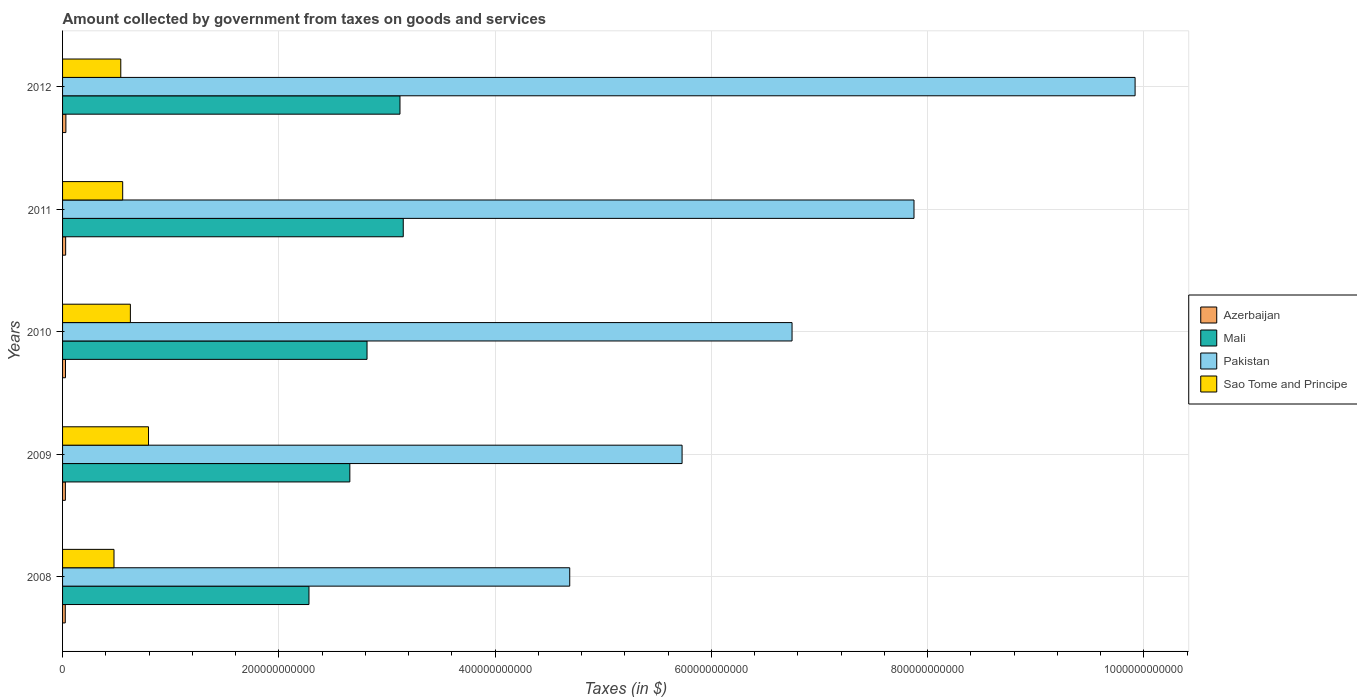How many different coloured bars are there?
Provide a short and direct response. 4. How many groups of bars are there?
Your answer should be compact. 5. Are the number of bars per tick equal to the number of legend labels?
Provide a succinct answer. Yes. How many bars are there on the 4th tick from the top?
Offer a very short reply. 4. How many bars are there on the 4th tick from the bottom?
Provide a succinct answer. 4. What is the label of the 3rd group of bars from the top?
Provide a succinct answer. 2010. In how many cases, is the number of bars for a given year not equal to the number of legend labels?
Offer a terse response. 0. What is the amount collected by government from taxes on goods and services in Sao Tome and Principe in 2011?
Your answer should be compact. 5.56e+1. Across all years, what is the maximum amount collected by government from taxes on goods and services in Mali?
Your answer should be compact. 3.15e+11. Across all years, what is the minimum amount collected by government from taxes on goods and services in Pakistan?
Make the answer very short. 4.69e+11. What is the total amount collected by government from taxes on goods and services in Sao Tome and Principe in the graph?
Your answer should be compact. 2.99e+11. What is the difference between the amount collected by government from taxes on goods and services in Azerbaijan in 2009 and that in 2010?
Keep it short and to the point. -1.03e+08. What is the difference between the amount collected by government from taxes on goods and services in Mali in 2011 and the amount collected by government from taxes on goods and services in Sao Tome and Principe in 2008?
Make the answer very short. 2.68e+11. What is the average amount collected by government from taxes on goods and services in Pakistan per year?
Offer a very short reply. 6.99e+11. In the year 2009, what is the difference between the amount collected by government from taxes on goods and services in Azerbaijan and amount collected by government from taxes on goods and services in Mali?
Provide a short and direct response. -2.63e+11. What is the ratio of the amount collected by government from taxes on goods and services in Azerbaijan in 2011 to that in 2012?
Offer a terse response. 0.93. Is the amount collected by government from taxes on goods and services in Pakistan in 2008 less than that in 2011?
Your response must be concise. Yes. What is the difference between the highest and the second highest amount collected by government from taxes on goods and services in Sao Tome and Principe?
Keep it short and to the point. 1.68e+1. What is the difference between the highest and the lowest amount collected by government from taxes on goods and services in Mali?
Keep it short and to the point. 8.72e+1. In how many years, is the amount collected by government from taxes on goods and services in Sao Tome and Principe greater than the average amount collected by government from taxes on goods and services in Sao Tome and Principe taken over all years?
Keep it short and to the point. 2. Is the sum of the amount collected by government from taxes on goods and services in Azerbaijan in 2009 and 2012 greater than the maximum amount collected by government from taxes on goods and services in Mali across all years?
Offer a terse response. No. Is it the case that in every year, the sum of the amount collected by government from taxes on goods and services in Mali and amount collected by government from taxes on goods and services in Sao Tome and Principe is greater than the sum of amount collected by government from taxes on goods and services in Azerbaijan and amount collected by government from taxes on goods and services in Pakistan?
Keep it short and to the point. No. What does the 3rd bar from the top in 2012 represents?
Give a very brief answer. Mali. What does the 1st bar from the bottom in 2010 represents?
Keep it short and to the point. Azerbaijan. Is it the case that in every year, the sum of the amount collected by government from taxes on goods and services in Sao Tome and Principe and amount collected by government from taxes on goods and services in Mali is greater than the amount collected by government from taxes on goods and services in Pakistan?
Give a very brief answer. No. Are all the bars in the graph horizontal?
Ensure brevity in your answer.  Yes. What is the difference between two consecutive major ticks on the X-axis?
Ensure brevity in your answer.  2.00e+11. Does the graph contain any zero values?
Make the answer very short. No. How many legend labels are there?
Keep it short and to the point. 4. What is the title of the graph?
Ensure brevity in your answer.  Amount collected by government from taxes on goods and services. What is the label or title of the X-axis?
Keep it short and to the point. Taxes (in $). What is the label or title of the Y-axis?
Your answer should be compact. Years. What is the Taxes (in $) in Azerbaijan in 2008?
Provide a short and direct response. 2.50e+09. What is the Taxes (in $) of Mali in 2008?
Your answer should be compact. 2.28e+11. What is the Taxes (in $) in Pakistan in 2008?
Offer a very short reply. 4.69e+11. What is the Taxes (in $) in Sao Tome and Principe in 2008?
Make the answer very short. 4.76e+1. What is the Taxes (in $) of Azerbaijan in 2009?
Give a very brief answer. 2.59e+09. What is the Taxes (in $) of Mali in 2009?
Provide a short and direct response. 2.66e+11. What is the Taxes (in $) in Pakistan in 2009?
Your answer should be very brief. 5.73e+11. What is the Taxes (in $) of Sao Tome and Principe in 2009?
Provide a short and direct response. 7.95e+1. What is the Taxes (in $) in Azerbaijan in 2010?
Make the answer very short. 2.70e+09. What is the Taxes (in $) in Mali in 2010?
Your response must be concise. 2.82e+11. What is the Taxes (in $) in Pakistan in 2010?
Offer a very short reply. 6.75e+11. What is the Taxes (in $) in Sao Tome and Principe in 2010?
Your answer should be very brief. 6.27e+1. What is the Taxes (in $) in Azerbaijan in 2011?
Make the answer very short. 2.87e+09. What is the Taxes (in $) of Mali in 2011?
Ensure brevity in your answer.  3.15e+11. What is the Taxes (in $) in Pakistan in 2011?
Your answer should be compact. 7.88e+11. What is the Taxes (in $) of Sao Tome and Principe in 2011?
Provide a short and direct response. 5.56e+1. What is the Taxes (in $) of Azerbaijan in 2012?
Your answer should be compact. 3.08e+09. What is the Taxes (in $) of Mali in 2012?
Offer a very short reply. 3.12e+11. What is the Taxes (in $) in Pakistan in 2012?
Keep it short and to the point. 9.92e+11. What is the Taxes (in $) of Sao Tome and Principe in 2012?
Your answer should be very brief. 5.38e+1. Across all years, what is the maximum Taxes (in $) of Azerbaijan?
Your answer should be compact. 3.08e+09. Across all years, what is the maximum Taxes (in $) of Mali?
Keep it short and to the point. 3.15e+11. Across all years, what is the maximum Taxes (in $) of Pakistan?
Keep it short and to the point. 9.92e+11. Across all years, what is the maximum Taxes (in $) in Sao Tome and Principe?
Provide a short and direct response. 7.95e+1. Across all years, what is the minimum Taxes (in $) of Azerbaijan?
Your response must be concise. 2.50e+09. Across all years, what is the minimum Taxes (in $) in Mali?
Ensure brevity in your answer.  2.28e+11. Across all years, what is the minimum Taxes (in $) of Pakistan?
Your answer should be compact. 4.69e+11. Across all years, what is the minimum Taxes (in $) in Sao Tome and Principe?
Your response must be concise. 4.76e+1. What is the total Taxes (in $) of Azerbaijan in the graph?
Your answer should be compact. 1.37e+1. What is the total Taxes (in $) of Mali in the graph?
Your response must be concise. 1.40e+12. What is the total Taxes (in $) in Pakistan in the graph?
Your answer should be very brief. 3.50e+12. What is the total Taxes (in $) in Sao Tome and Principe in the graph?
Keep it short and to the point. 2.99e+11. What is the difference between the Taxes (in $) of Azerbaijan in 2008 and that in 2009?
Give a very brief answer. -9.02e+07. What is the difference between the Taxes (in $) in Mali in 2008 and that in 2009?
Your answer should be compact. -3.78e+1. What is the difference between the Taxes (in $) of Pakistan in 2008 and that in 2009?
Offer a terse response. -1.04e+11. What is the difference between the Taxes (in $) in Sao Tome and Principe in 2008 and that in 2009?
Ensure brevity in your answer.  -3.19e+1. What is the difference between the Taxes (in $) in Azerbaijan in 2008 and that in 2010?
Offer a terse response. -1.93e+08. What is the difference between the Taxes (in $) of Mali in 2008 and that in 2010?
Provide a short and direct response. -5.37e+1. What is the difference between the Taxes (in $) in Pakistan in 2008 and that in 2010?
Provide a short and direct response. -2.06e+11. What is the difference between the Taxes (in $) of Sao Tome and Principe in 2008 and that in 2010?
Your response must be concise. -1.52e+1. What is the difference between the Taxes (in $) in Azerbaijan in 2008 and that in 2011?
Your answer should be very brief. -3.62e+08. What is the difference between the Taxes (in $) of Mali in 2008 and that in 2011?
Ensure brevity in your answer.  -8.72e+1. What is the difference between the Taxes (in $) in Pakistan in 2008 and that in 2011?
Provide a succinct answer. -3.18e+11. What is the difference between the Taxes (in $) of Sao Tome and Principe in 2008 and that in 2011?
Your answer should be very brief. -8.04e+09. What is the difference between the Taxes (in $) in Azerbaijan in 2008 and that in 2012?
Provide a succinct answer. -5.77e+08. What is the difference between the Taxes (in $) in Mali in 2008 and that in 2012?
Provide a succinct answer. -8.42e+1. What is the difference between the Taxes (in $) of Pakistan in 2008 and that in 2012?
Ensure brevity in your answer.  -5.23e+11. What is the difference between the Taxes (in $) in Sao Tome and Principe in 2008 and that in 2012?
Offer a very short reply. -6.28e+09. What is the difference between the Taxes (in $) of Azerbaijan in 2009 and that in 2010?
Offer a very short reply. -1.03e+08. What is the difference between the Taxes (in $) in Mali in 2009 and that in 2010?
Ensure brevity in your answer.  -1.59e+1. What is the difference between the Taxes (in $) of Pakistan in 2009 and that in 2010?
Your answer should be compact. -1.02e+11. What is the difference between the Taxes (in $) of Sao Tome and Principe in 2009 and that in 2010?
Offer a very short reply. 1.68e+1. What is the difference between the Taxes (in $) of Azerbaijan in 2009 and that in 2011?
Your answer should be very brief. -2.72e+08. What is the difference between the Taxes (in $) of Mali in 2009 and that in 2011?
Ensure brevity in your answer.  -4.94e+1. What is the difference between the Taxes (in $) of Pakistan in 2009 and that in 2011?
Provide a succinct answer. -2.14e+11. What is the difference between the Taxes (in $) in Sao Tome and Principe in 2009 and that in 2011?
Give a very brief answer. 2.39e+1. What is the difference between the Taxes (in $) in Azerbaijan in 2009 and that in 2012?
Provide a short and direct response. -4.87e+08. What is the difference between the Taxes (in $) of Mali in 2009 and that in 2012?
Your answer should be compact. -4.64e+1. What is the difference between the Taxes (in $) of Pakistan in 2009 and that in 2012?
Keep it short and to the point. -4.19e+11. What is the difference between the Taxes (in $) in Sao Tome and Principe in 2009 and that in 2012?
Keep it short and to the point. 2.57e+1. What is the difference between the Taxes (in $) of Azerbaijan in 2010 and that in 2011?
Offer a terse response. -1.70e+08. What is the difference between the Taxes (in $) in Mali in 2010 and that in 2011?
Keep it short and to the point. -3.35e+1. What is the difference between the Taxes (in $) in Pakistan in 2010 and that in 2011?
Offer a terse response. -1.13e+11. What is the difference between the Taxes (in $) in Sao Tome and Principe in 2010 and that in 2011?
Offer a very short reply. 7.12e+09. What is the difference between the Taxes (in $) of Azerbaijan in 2010 and that in 2012?
Your answer should be compact. -3.85e+08. What is the difference between the Taxes (in $) of Mali in 2010 and that in 2012?
Your answer should be very brief. -3.05e+1. What is the difference between the Taxes (in $) in Pakistan in 2010 and that in 2012?
Offer a very short reply. -3.17e+11. What is the difference between the Taxes (in $) in Sao Tome and Principe in 2010 and that in 2012?
Ensure brevity in your answer.  8.88e+09. What is the difference between the Taxes (in $) in Azerbaijan in 2011 and that in 2012?
Provide a short and direct response. -2.15e+08. What is the difference between the Taxes (in $) in Mali in 2011 and that in 2012?
Make the answer very short. 3.02e+09. What is the difference between the Taxes (in $) in Pakistan in 2011 and that in 2012?
Offer a terse response. -2.04e+11. What is the difference between the Taxes (in $) of Sao Tome and Principe in 2011 and that in 2012?
Your answer should be compact. 1.76e+09. What is the difference between the Taxes (in $) of Azerbaijan in 2008 and the Taxes (in $) of Mali in 2009?
Keep it short and to the point. -2.63e+11. What is the difference between the Taxes (in $) in Azerbaijan in 2008 and the Taxes (in $) in Pakistan in 2009?
Offer a very short reply. -5.70e+11. What is the difference between the Taxes (in $) in Azerbaijan in 2008 and the Taxes (in $) in Sao Tome and Principe in 2009?
Your answer should be compact. -7.70e+1. What is the difference between the Taxes (in $) of Mali in 2008 and the Taxes (in $) of Pakistan in 2009?
Your answer should be compact. -3.45e+11. What is the difference between the Taxes (in $) in Mali in 2008 and the Taxes (in $) in Sao Tome and Principe in 2009?
Your answer should be compact. 1.48e+11. What is the difference between the Taxes (in $) of Pakistan in 2008 and the Taxes (in $) of Sao Tome and Principe in 2009?
Your answer should be compact. 3.90e+11. What is the difference between the Taxes (in $) in Azerbaijan in 2008 and the Taxes (in $) in Mali in 2010?
Ensure brevity in your answer.  -2.79e+11. What is the difference between the Taxes (in $) of Azerbaijan in 2008 and the Taxes (in $) of Pakistan in 2010?
Give a very brief answer. -6.72e+11. What is the difference between the Taxes (in $) of Azerbaijan in 2008 and the Taxes (in $) of Sao Tome and Principe in 2010?
Provide a short and direct response. -6.02e+1. What is the difference between the Taxes (in $) in Mali in 2008 and the Taxes (in $) in Pakistan in 2010?
Provide a succinct answer. -4.47e+11. What is the difference between the Taxes (in $) of Mali in 2008 and the Taxes (in $) of Sao Tome and Principe in 2010?
Ensure brevity in your answer.  1.65e+11. What is the difference between the Taxes (in $) of Pakistan in 2008 and the Taxes (in $) of Sao Tome and Principe in 2010?
Provide a succinct answer. 4.06e+11. What is the difference between the Taxes (in $) in Azerbaijan in 2008 and the Taxes (in $) in Mali in 2011?
Provide a short and direct response. -3.13e+11. What is the difference between the Taxes (in $) of Azerbaijan in 2008 and the Taxes (in $) of Pakistan in 2011?
Give a very brief answer. -7.85e+11. What is the difference between the Taxes (in $) of Azerbaijan in 2008 and the Taxes (in $) of Sao Tome and Principe in 2011?
Ensure brevity in your answer.  -5.31e+1. What is the difference between the Taxes (in $) in Mali in 2008 and the Taxes (in $) in Pakistan in 2011?
Make the answer very short. -5.60e+11. What is the difference between the Taxes (in $) of Mali in 2008 and the Taxes (in $) of Sao Tome and Principe in 2011?
Offer a very short reply. 1.72e+11. What is the difference between the Taxes (in $) of Pakistan in 2008 and the Taxes (in $) of Sao Tome and Principe in 2011?
Offer a very short reply. 4.13e+11. What is the difference between the Taxes (in $) in Azerbaijan in 2008 and the Taxes (in $) in Mali in 2012?
Offer a terse response. -3.10e+11. What is the difference between the Taxes (in $) in Azerbaijan in 2008 and the Taxes (in $) in Pakistan in 2012?
Keep it short and to the point. -9.89e+11. What is the difference between the Taxes (in $) of Azerbaijan in 2008 and the Taxes (in $) of Sao Tome and Principe in 2012?
Your response must be concise. -5.13e+1. What is the difference between the Taxes (in $) of Mali in 2008 and the Taxes (in $) of Pakistan in 2012?
Provide a succinct answer. -7.64e+11. What is the difference between the Taxes (in $) of Mali in 2008 and the Taxes (in $) of Sao Tome and Principe in 2012?
Your response must be concise. 1.74e+11. What is the difference between the Taxes (in $) of Pakistan in 2008 and the Taxes (in $) of Sao Tome and Principe in 2012?
Provide a short and direct response. 4.15e+11. What is the difference between the Taxes (in $) in Azerbaijan in 2009 and the Taxes (in $) in Mali in 2010?
Make the answer very short. -2.79e+11. What is the difference between the Taxes (in $) of Azerbaijan in 2009 and the Taxes (in $) of Pakistan in 2010?
Keep it short and to the point. -6.72e+11. What is the difference between the Taxes (in $) in Azerbaijan in 2009 and the Taxes (in $) in Sao Tome and Principe in 2010?
Your response must be concise. -6.01e+1. What is the difference between the Taxes (in $) of Mali in 2009 and the Taxes (in $) of Pakistan in 2010?
Your answer should be very brief. -4.09e+11. What is the difference between the Taxes (in $) of Mali in 2009 and the Taxes (in $) of Sao Tome and Principe in 2010?
Your answer should be very brief. 2.03e+11. What is the difference between the Taxes (in $) in Pakistan in 2009 and the Taxes (in $) in Sao Tome and Principe in 2010?
Your response must be concise. 5.10e+11. What is the difference between the Taxes (in $) of Azerbaijan in 2009 and the Taxes (in $) of Mali in 2011?
Provide a short and direct response. -3.13e+11. What is the difference between the Taxes (in $) of Azerbaijan in 2009 and the Taxes (in $) of Pakistan in 2011?
Your response must be concise. -7.85e+11. What is the difference between the Taxes (in $) in Azerbaijan in 2009 and the Taxes (in $) in Sao Tome and Principe in 2011?
Keep it short and to the point. -5.30e+1. What is the difference between the Taxes (in $) of Mali in 2009 and the Taxes (in $) of Pakistan in 2011?
Give a very brief answer. -5.22e+11. What is the difference between the Taxes (in $) in Mali in 2009 and the Taxes (in $) in Sao Tome and Principe in 2011?
Keep it short and to the point. 2.10e+11. What is the difference between the Taxes (in $) in Pakistan in 2009 and the Taxes (in $) in Sao Tome and Principe in 2011?
Make the answer very short. 5.17e+11. What is the difference between the Taxes (in $) of Azerbaijan in 2009 and the Taxes (in $) of Mali in 2012?
Offer a terse response. -3.09e+11. What is the difference between the Taxes (in $) of Azerbaijan in 2009 and the Taxes (in $) of Pakistan in 2012?
Offer a very short reply. -9.89e+11. What is the difference between the Taxes (in $) in Azerbaijan in 2009 and the Taxes (in $) in Sao Tome and Principe in 2012?
Offer a very short reply. -5.13e+1. What is the difference between the Taxes (in $) of Mali in 2009 and the Taxes (in $) of Pakistan in 2012?
Your answer should be very brief. -7.26e+11. What is the difference between the Taxes (in $) in Mali in 2009 and the Taxes (in $) in Sao Tome and Principe in 2012?
Offer a very short reply. 2.12e+11. What is the difference between the Taxes (in $) of Pakistan in 2009 and the Taxes (in $) of Sao Tome and Principe in 2012?
Offer a terse response. 5.19e+11. What is the difference between the Taxes (in $) of Azerbaijan in 2010 and the Taxes (in $) of Mali in 2011?
Provide a short and direct response. -3.12e+11. What is the difference between the Taxes (in $) of Azerbaijan in 2010 and the Taxes (in $) of Pakistan in 2011?
Offer a very short reply. -7.85e+11. What is the difference between the Taxes (in $) of Azerbaijan in 2010 and the Taxes (in $) of Sao Tome and Principe in 2011?
Offer a very short reply. -5.29e+1. What is the difference between the Taxes (in $) of Mali in 2010 and the Taxes (in $) of Pakistan in 2011?
Provide a succinct answer. -5.06e+11. What is the difference between the Taxes (in $) of Mali in 2010 and the Taxes (in $) of Sao Tome and Principe in 2011?
Offer a very short reply. 2.26e+11. What is the difference between the Taxes (in $) in Pakistan in 2010 and the Taxes (in $) in Sao Tome and Principe in 2011?
Provide a short and direct response. 6.19e+11. What is the difference between the Taxes (in $) of Azerbaijan in 2010 and the Taxes (in $) of Mali in 2012?
Offer a terse response. -3.09e+11. What is the difference between the Taxes (in $) in Azerbaijan in 2010 and the Taxes (in $) in Pakistan in 2012?
Give a very brief answer. -9.89e+11. What is the difference between the Taxes (in $) in Azerbaijan in 2010 and the Taxes (in $) in Sao Tome and Principe in 2012?
Your response must be concise. -5.12e+1. What is the difference between the Taxes (in $) of Mali in 2010 and the Taxes (in $) of Pakistan in 2012?
Keep it short and to the point. -7.10e+11. What is the difference between the Taxes (in $) in Mali in 2010 and the Taxes (in $) in Sao Tome and Principe in 2012?
Provide a short and direct response. 2.28e+11. What is the difference between the Taxes (in $) of Pakistan in 2010 and the Taxes (in $) of Sao Tome and Principe in 2012?
Your answer should be very brief. 6.21e+11. What is the difference between the Taxes (in $) of Azerbaijan in 2011 and the Taxes (in $) of Mali in 2012?
Provide a succinct answer. -3.09e+11. What is the difference between the Taxes (in $) in Azerbaijan in 2011 and the Taxes (in $) in Pakistan in 2012?
Provide a short and direct response. -9.89e+11. What is the difference between the Taxes (in $) of Azerbaijan in 2011 and the Taxes (in $) of Sao Tome and Principe in 2012?
Your answer should be very brief. -5.10e+1. What is the difference between the Taxes (in $) of Mali in 2011 and the Taxes (in $) of Pakistan in 2012?
Your response must be concise. -6.77e+11. What is the difference between the Taxes (in $) in Mali in 2011 and the Taxes (in $) in Sao Tome and Principe in 2012?
Make the answer very short. 2.61e+11. What is the difference between the Taxes (in $) of Pakistan in 2011 and the Taxes (in $) of Sao Tome and Principe in 2012?
Your answer should be compact. 7.34e+11. What is the average Taxes (in $) of Azerbaijan per year?
Your response must be concise. 2.75e+09. What is the average Taxes (in $) in Mali per year?
Offer a very short reply. 2.80e+11. What is the average Taxes (in $) in Pakistan per year?
Offer a terse response. 6.99e+11. What is the average Taxes (in $) of Sao Tome and Principe per year?
Offer a terse response. 5.98e+1. In the year 2008, what is the difference between the Taxes (in $) in Azerbaijan and Taxes (in $) in Mali?
Offer a terse response. -2.25e+11. In the year 2008, what is the difference between the Taxes (in $) in Azerbaijan and Taxes (in $) in Pakistan?
Offer a very short reply. -4.67e+11. In the year 2008, what is the difference between the Taxes (in $) of Azerbaijan and Taxes (in $) of Sao Tome and Principe?
Keep it short and to the point. -4.51e+1. In the year 2008, what is the difference between the Taxes (in $) of Mali and Taxes (in $) of Pakistan?
Offer a terse response. -2.41e+11. In the year 2008, what is the difference between the Taxes (in $) of Mali and Taxes (in $) of Sao Tome and Principe?
Keep it short and to the point. 1.80e+11. In the year 2008, what is the difference between the Taxes (in $) in Pakistan and Taxes (in $) in Sao Tome and Principe?
Offer a very short reply. 4.22e+11. In the year 2009, what is the difference between the Taxes (in $) of Azerbaijan and Taxes (in $) of Mali?
Keep it short and to the point. -2.63e+11. In the year 2009, what is the difference between the Taxes (in $) in Azerbaijan and Taxes (in $) in Pakistan?
Your response must be concise. -5.70e+11. In the year 2009, what is the difference between the Taxes (in $) of Azerbaijan and Taxes (in $) of Sao Tome and Principe?
Provide a succinct answer. -7.69e+1. In the year 2009, what is the difference between the Taxes (in $) in Mali and Taxes (in $) in Pakistan?
Your response must be concise. -3.07e+11. In the year 2009, what is the difference between the Taxes (in $) in Mali and Taxes (in $) in Sao Tome and Principe?
Offer a terse response. 1.86e+11. In the year 2009, what is the difference between the Taxes (in $) of Pakistan and Taxes (in $) of Sao Tome and Principe?
Offer a terse response. 4.93e+11. In the year 2010, what is the difference between the Taxes (in $) of Azerbaijan and Taxes (in $) of Mali?
Your response must be concise. -2.79e+11. In the year 2010, what is the difference between the Taxes (in $) of Azerbaijan and Taxes (in $) of Pakistan?
Offer a very short reply. -6.72e+11. In the year 2010, what is the difference between the Taxes (in $) in Azerbaijan and Taxes (in $) in Sao Tome and Principe?
Make the answer very short. -6.00e+1. In the year 2010, what is the difference between the Taxes (in $) of Mali and Taxes (in $) of Pakistan?
Ensure brevity in your answer.  -3.93e+11. In the year 2010, what is the difference between the Taxes (in $) of Mali and Taxes (in $) of Sao Tome and Principe?
Offer a very short reply. 2.19e+11. In the year 2010, what is the difference between the Taxes (in $) in Pakistan and Taxes (in $) in Sao Tome and Principe?
Make the answer very short. 6.12e+11. In the year 2011, what is the difference between the Taxes (in $) in Azerbaijan and Taxes (in $) in Mali?
Make the answer very short. -3.12e+11. In the year 2011, what is the difference between the Taxes (in $) of Azerbaijan and Taxes (in $) of Pakistan?
Your answer should be very brief. -7.85e+11. In the year 2011, what is the difference between the Taxes (in $) in Azerbaijan and Taxes (in $) in Sao Tome and Principe?
Your answer should be compact. -5.27e+1. In the year 2011, what is the difference between the Taxes (in $) of Mali and Taxes (in $) of Pakistan?
Your response must be concise. -4.72e+11. In the year 2011, what is the difference between the Taxes (in $) in Mali and Taxes (in $) in Sao Tome and Principe?
Your response must be concise. 2.60e+11. In the year 2011, what is the difference between the Taxes (in $) of Pakistan and Taxes (in $) of Sao Tome and Principe?
Offer a terse response. 7.32e+11. In the year 2012, what is the difference between the Taxes (in $) of Azerbaijan and Taxes (in $) of Mali?
Provide a succinct answer. -3.09e+11. In the year 2012, what is the difference between the Taxes (in $) of Azerbaijan and Taxes (in $) of Pakistan?
Offer a very short reply. -9.89e+11. In the year 2012, what is the difference between the Taxes (in $) in Azerbaijan and Taxes (in $) in Sao Tome and Principe?
Provide a short and direct response. -5.08e+1. In the year 2012, what is the difference between the Taxes (in $) in Mali and Taxes (in $) in Pakistan?
Provide a succinct answer. -6.80e+11. In the year 2012, what is the difference between the Taxes (in $) of Mali and Taxes (in $) of Sao Tome and Principe?
Provide a short and direct response. 2.58e+11. In the year 2012, what is the difference between the Taxes (in $) in Pakistan and Taxes (in $) in Sao Tome and Principe?
Provide a succinct answer. 9.38e+11. What is the ratio of the Taxes (in $) of Azerbaijan in 2008 to that in 2009?
Provide a short and direct response. 0.97. What is the ratio of the Taxes (in $) in Mali in 2008 to that in 2009?
Make the answer very short. 0.86. What is the ratio of the Taxes (in $) in Pakistan in 2008 to that in 2009?
Provide a short and direct response. 0.82. What is the ratio of the Taxes (in $) in Sao Tome and Principe in 2008 to that in 2009?
Your response must be concise. 0.6. What is the ratio of the Taxes (in $) of Azerbaijan in 2008 to that in 2010?
Provide a short and direct response. 0.93. What is the ratio of the Taxes (in $) in Mali in 2008 to that in 2010?
Your answer should be compact. 0.81. What is the ratio of the Taxes (in $) of Pakistan in 2008 to that in 2010?
Offer a very short reply. 0.7. What is the ratio of the Taxes (in $) in Sao Tome and Principe in 2008 to that in 2010?
Your answer should be very brief. 0.76. What is the ratio of the Taxes (in $) in Azerbaijan in 2008 to that in 2011?
Keep it short and to the point. 0.87. What is the ratio of the Taxes (in $) of Mali in 2008 to that in 2011?
Ensure brevity in your answer.  0.72. What is the ratio of the Taxes (in $) of Pakistan in 2008 to that in 2011?
Offer a terse response. 0.6. What is the ratio of the Taxes (in $) of Sao Tome and Principe in 2008 to that in 2011?
Keep it short and to the point. 0.86. What is the ratio of the Taxes (in $) of Azerbaijan in 2008 to that in 2012?
Offer a terse response. 0.81. What is the ratio of the Taxes (in $) in Mali in 2008 to that in 2012?
Ensure brevity in your answer.  0.73. What is the ratio of the Taxes (in $) in Pakistan in 2008 to that in 2012?
Offer a terse response. 0.47. What is the ratio of the Taxes (in $) in Sao Tome and Principe in 2008 to that in 2012?
Make the answer very short. 0.88. What is the ratio of the Taxes (in $) in Azerbaijan in 2009 to that in 2010?
Offer a terse response. 0.96. What is the ratio of the Taxes (in $) of Mali in 2009 to that in 2010?
Your response must be concise. 0.94. What is the ratio of the Taxes (in $) in Pakistan in 2009 to that in 2010?
Ensure brevity in your answer.  0.85. What is the ratio of the Taxes (in $) in Sao Tome and Principe in 2009 to that in 2010?
Ensure brevity in your answer.  1.27. What is the ratio of the Taxes (in $) of Azerbaijan in 2009 to that in 2011?
Keep it short and to the point. 0.91. What is the ratio of the Taxes (in $) of Mali in 2009 to that in 2011?
Provide a succinct answer. 0.84. What is the ratio of the Taxes (in $) in Pakistan in 2009 to that in 2011?
Ensure brevity in your answer.  0.73. What is the ratio of the Taxes (in $) of Sao Tome and Principe in 2009 to that in 2011?
Offer a very short reply. 1.43. What is the ratio of the Taxes (in $) in Azerbaijan in 2009 to that in 2012?
Your answer should be very brief. 0.84. What is the ratio of the Taxes (in $) in Mali in 2009 to that in 2012?
Give a very brief answer. 0.85. What is the ratio of the Taxes (in $) in Pakistan in 2009 to that in 2012?
Give a very brief answer. 0.58. What is the ratio of the Taxes (in $) in Sao Tome and Principe in 2009 to that in 2012?
Provide a succinct answer. 1.48. What is the ratio of the Taxes (in $) in Azerbaijan in 2010 to that in 2011?
Your answer should be compact. 0.94. What is the ratio of the Taxes (in $) in Mali in 2010 to that in 2011?
Ensure brevity in your answer.  0.89. What is the ratio of the Taxes (in $) in Pakistan in 2010 to that in 2011?
Make the answer very short. 0.86. What is the ratio of the Taxes (in $) of Sao Tome and Principe in 2010 to that in 2011?
Provide a succinct answer. 1.13. What is the ratio of the Taxes (in $) in Azerbaijan in 2010 to that in 2012?
Offer a terse response. 0.88. What is the ratio of the Taxes (in $) of Mali in 2010 to that in 2012?
Give a very brief answer. 0.9. What is the ratio of the Taxes (in $) of Pakistan in 2010 to that in 2012?
Make the answer very short. 0.68. What is the ratio of the Taxes (in $) of Sao Tome and Principe in 2010 to that in 2012?
Your response must be concise. 1.16. What is the ratio of the Taxes (in $) of Azerbaijan in 2011 to that in 2012?
Make the answer very short. 0.93. What is the ratio of the Taxes (in $) in Mali in 2011 to that in 2012?
Your answer should be very brief. 1.01. What is the ratio of the Taxes (in $) in Pakistan in 2011 to that in 2012?
Ensure brevity in your answer.  0.79. What is the ratio of the Taxes (in $) of Sao Tome and Principe in 2011 to that in 2012?
Ensure brevity in your answer.  1.03. What is the difference between the highest and the second highest Taxes (in $) of Azerbaijan?
Provide a succinct answer. 2.15e+08. What is the difference between the highest and the second highest Taxes (in $) in Mali?
Ensure brevity in your answer.  3.02e+09. What is the difference between the highest and the second highest Taxes (in $) of Pakistan?
Offer a very short reply. 2.04e+11. What is the difference between the highest and the second highest Taxes (in $) in Sao Tome and Principe?
Provide a short and direct response. 1.68e+1. What is the difference between the highest and the lowest Taxes (in $) of Azerbaijan?
Make the answer very short. 5.77e+08. What is the difference between the highest and the lowest Taxes (in $) of Mali?
Provide a short and direct response. 8.72e+1. What is the difference between the highest and the lowest Taxes (in $) in Pakistan?
Give a very brief answer. 5.23e+11. What is the difference between the highest and the lowest Taxes (in $) in Sao Tome and Principe?
Offer a very short reply. 3.19e+1. 